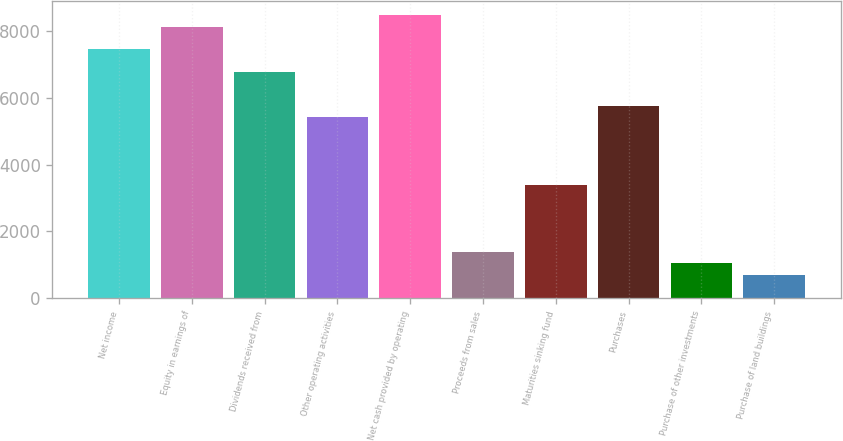<chart> <loc_0><loc_0><loc_500><loc_500><bar_chart><fcel>Net income<fcel>Equity in earnings of<fcel>Dividends received from<fcel>Other operating activities<fcel>Net cash provided by operating<fcel>Proceeds from sales<fcel>Maturities sinking fund<fcel>Purchases<fcel>Purchase of other investments<fcel>Purchase of land buildings<nl><fcel>7447.2<fcel>8121.4<fcel>6773<fcel>5424.6<fcel>8458.5<fcel>1379.4<fcel>3402<fcel>5761.7<fcel>1042.3<fcel>705.2<nl></chart> 